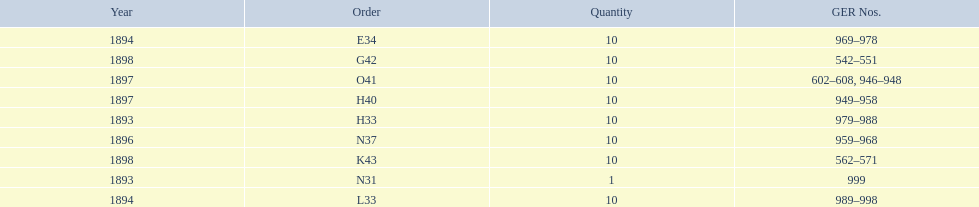Was the quantity higher in 1894 or 1893? 1894. 